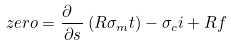<formula> <loc_0><loc_0><loc_500><loc_500>z e r o = \frac { \partial \ } { \partial s } \left ( R \sigma _ { m } t \right ) - \sigma _ { c } i + R f</formula> 